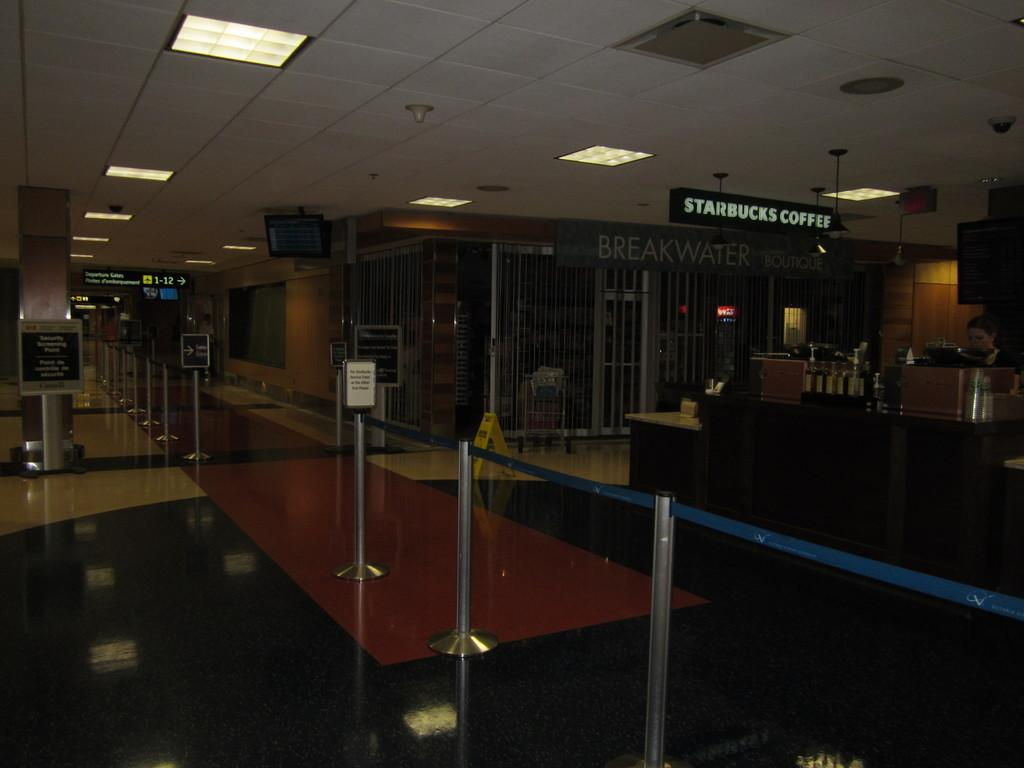What is the main subject in the middle of the image? There is a queue manager in the middle of the image. Who else can be seen in the image? There is a woman on the right side of the image. What is visible at the top of the image? There is a wall at the top of the image. What type of lighting is present in the image? Ceiling lights are visible in the image. What type of meat is being served in the image? There is no meat present in the image. What color is the woman's hair in the image? The provided facts do not mention the color of the woman's hair, so we cannot answer that question. 